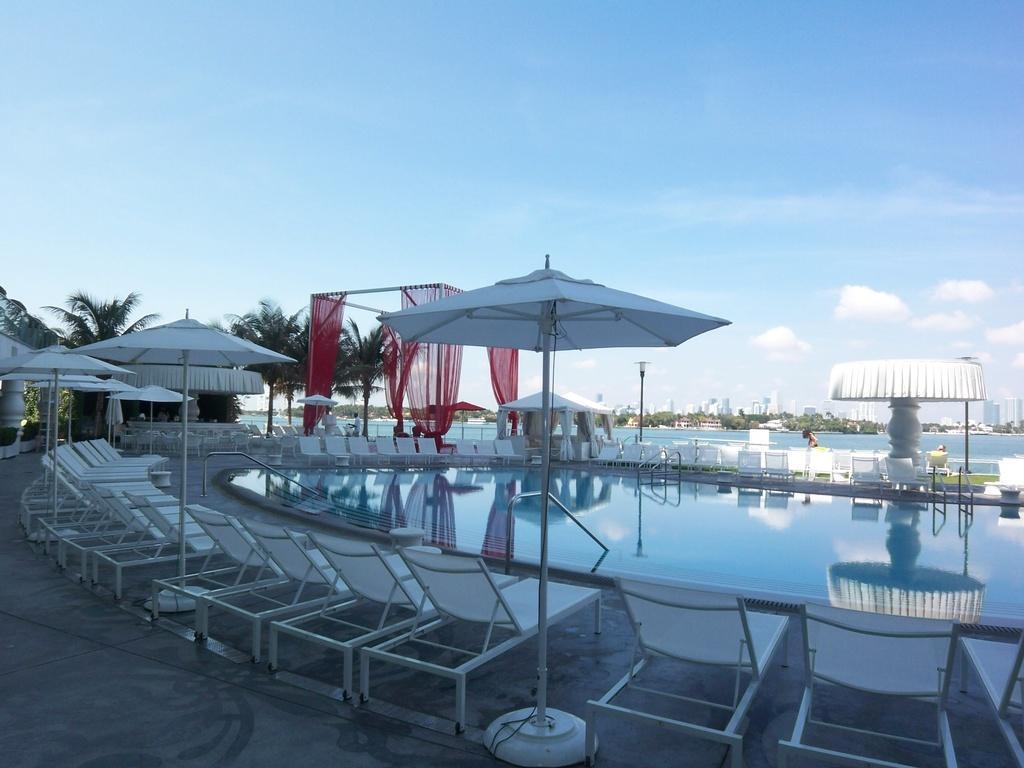Please provide a concise description of this image. In this image we can see a swimming pool, beach beds, umbrellas and trees. The sky is in blue color with some clouds. 